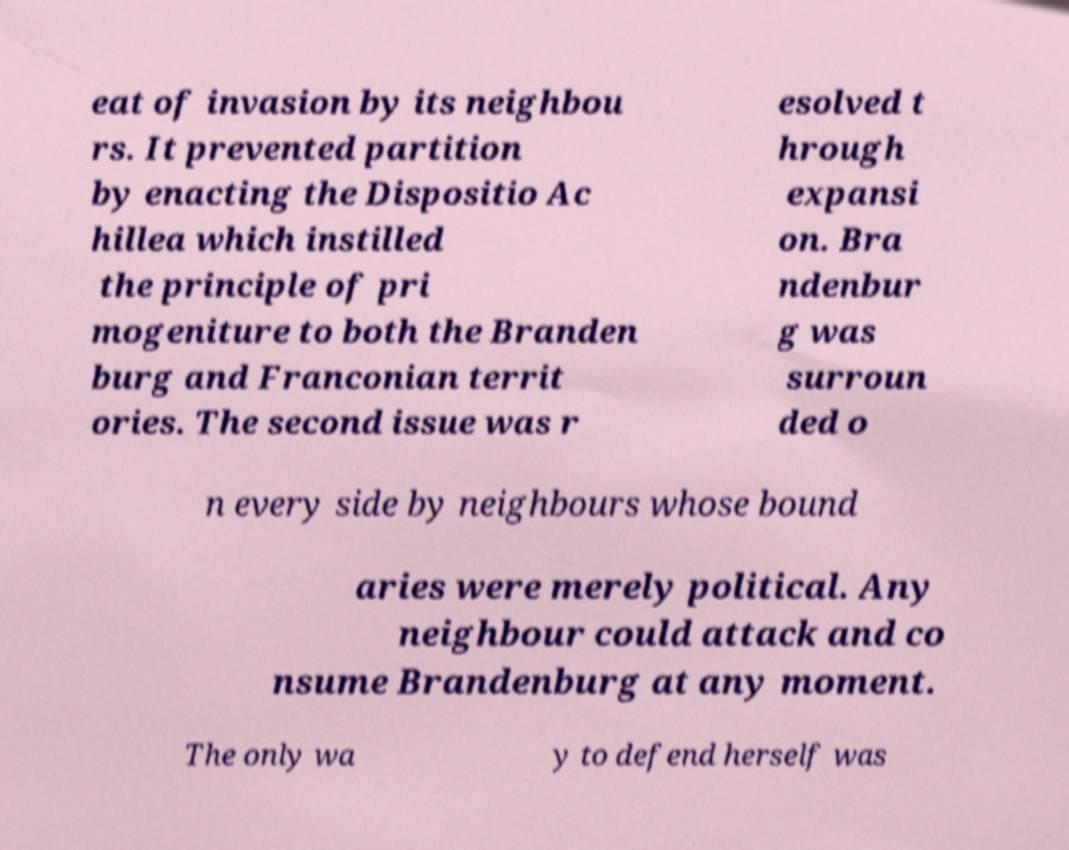For documentation purposes, I need the text within this image transcribed. Could you provide that? eat of invasion by its neighbou rs. It prevented partition by enacting the Dispositio Ac hillea which instilled the principle of pri mogeniture to both the Branden burg and Franconian territ ories. The second issue was r esolved t hrough expansi on. Bra ndenbur g was surroun ded o n every side by neighbours whose bound aries were merely political. Any neighbour could attack and co nsume Brandenburg at any moment. The only wa y to defend herself was 